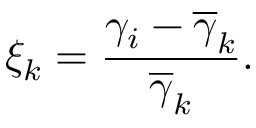Convert formula to latex. <formula><loc_0><loc_0><loc_500><loc_500>\xi _ { k } = \frac { \gamma _ { i } - \overline { \gamma } _ { k } } { \overline { \gamma } _ { k } } .</formula> 